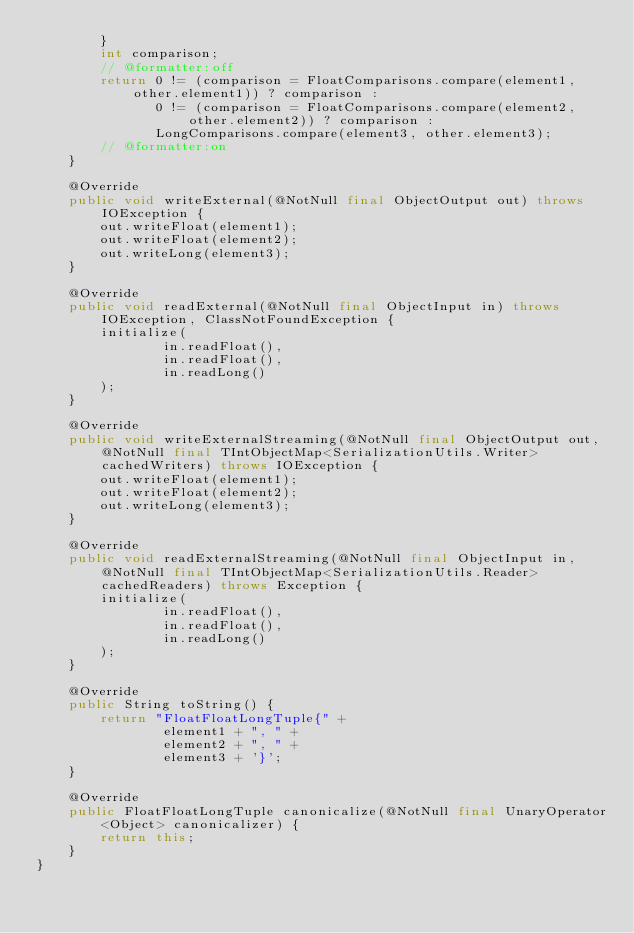Convert code to text. <code><loc_0><loc_0><loc_500><loc_500><_Java_>        }
        int comparison;
        // @formatter:off
        return 0 != (comparison = FloatComparisons.compare(element1, other.element1)) ? comparison :
               0 != (comparison = FloatComparisons.compare(element2, other.element2)) ? comparison :
               LongComparisons.compare(element3, other.element3);
        // @formatter:on
    }

    @Override
    public void writeExternal(@NotNull final ObjectOutput out) throws IOException {
        out.writeFloat(element1);
        out.writeFloat(element2);
        out.writeLong(element3);
    }

    @Override
    public void readExternal(@NotNull final ObjectInput in) throws IOException, ClassNotFoundException {
        initialize(
                in.readFloat(),
                in.readFloat(),
                in.readLong()
        );
    }

    @Override
    public void writeExternalStreaming(@NotNull final ObjectOutput out, @NotNull final TIntObjectMap<SerializationUtils.Writer> cachedWriters) throws IOException {
        out.writeFloat(element1);
        out.writeFloat(element2);
        out.writeLong(element3);
    }

    @Override
    public void readExternalStreaming(@NotNull final ObjectInput in, @NotNull final TIntObjectMap<SerializationUtils.Reader> cachedReaders) throws Exception {
        initialize(
                in.readFloat(),
                in.readFloat(),
                in.readLong()
        );
    }

    @Override
    public String toString() {
        return "FloatFloatLongTuple{" +
                element1 + ", " +
                element2 + ", " +
                element3 + '}';
    }

    @Override
    public FloatFloatLongTuple canonicalize(@NotNull final UnaryOperator<Object> canonicalizer) {
        return this;
    }
}
</code> 